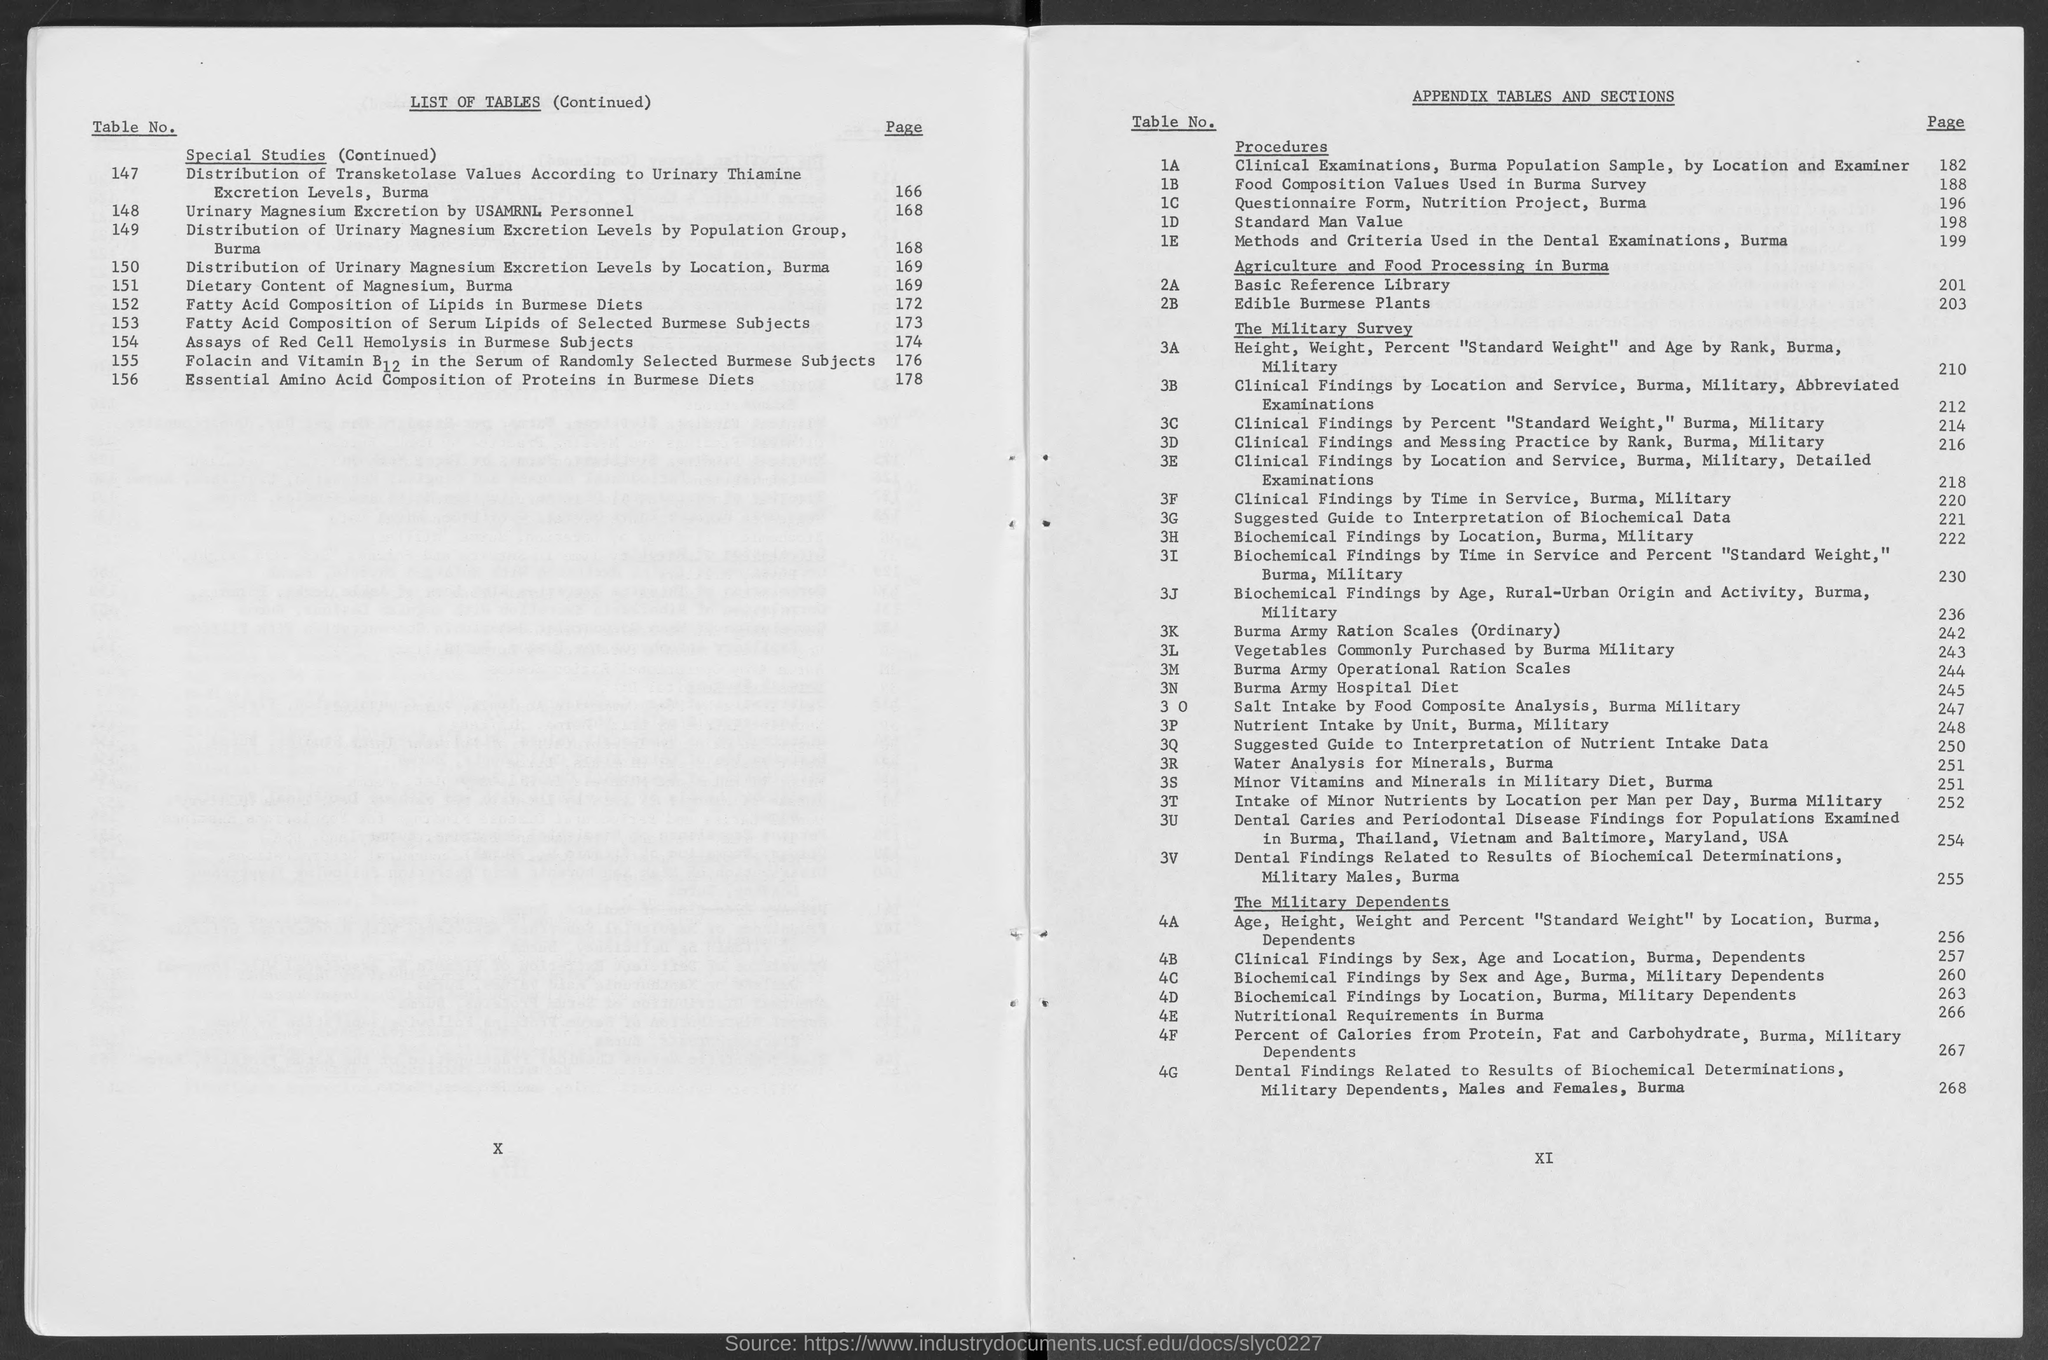Specify some key components in this picture. Please provide the page number for Table No. 2A, which is 201... The page number for Table No. 3A is 210. I am requesting information on the page number for Table no. 1D. The page number for Table No. 3B is 212. The page number for table no. 2B is 203. 